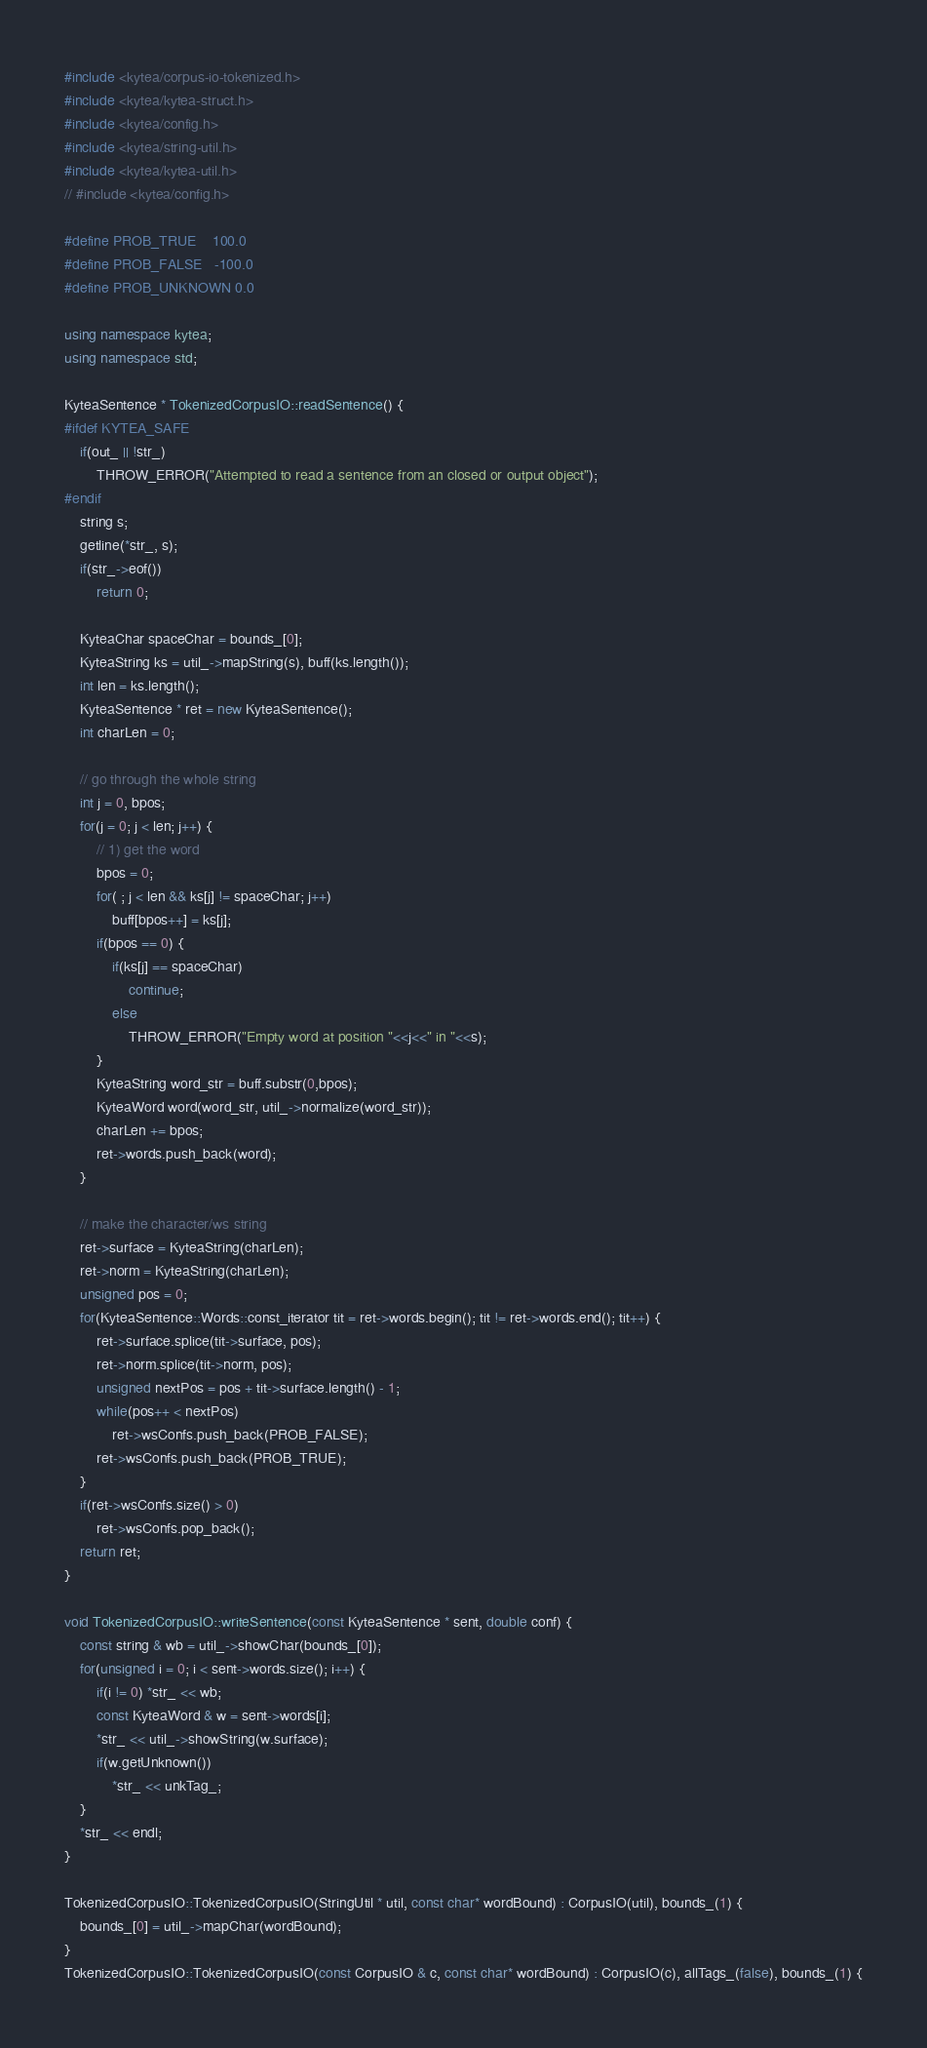Convert code to text. <code><loc_0><loc_0><loc_500><loc_500><_C++_>#include <kytea/corpus-io-tokenized.h>
#include <kytea/kytea-struct.h>
#include <kytea/config.h>
#include <kytea/string-util.h>
#include <kytea/kytea-util.h>
// #include <kytea/config.h>

#define PROB_TRUE    100.0
#define PROB_FALSE   -100.0
#define PROB_UNKNOWN 0.0

using namespace kytea;
using namespace std;

KyteaSentence * TokenizedCorpusIO::readSentence() {
#ifdef KYTEA_SAFE
    if(out_ || !str_)
        THROW_ERROR("Attempted to read a sentence from an closed or output object");
#endif
    string s;
    getline(*str_, s);
    if(str_->eof())
        return 0;

    KyteaChar spaceChar = bounds_[0];
    KyteaString ks = util_->mapString(s), buff(ks.length());
    int len = ks.length();
    KyteaSentence * ret = new KyteaSentence();
    int charLen = 0;

    // go through the whole string
    int j = 0, bpos;
    for(j = 0; j < len; j++) {
        // 1) get the word
        bpos = 0;
        for( ; j < len && ks[j] != spaceChar; j++)
            buff[bpos++] = ks[j];
        if(bpos == 0) {
            if(ks[j] == spaceChar)
                continue;
            else
                THROW_ERROR("Empty word at position "<<j<<" in "<<s);
        }
        KyteaString word_str = buff.substr(0,bpos);
        KyteaWord word(word_str, util_->normalize(word_str));
        charLen += bpos;
        ret->words.push_back(word);
    }

    // make the character/ws string
    ret->surface = KyteaString(charLen);
    ret->norm = KyteaString(charLen);
    unsigned pos = 0;
    for(KyteaSentence::Words::const_iterator tit = ret->words.begin(); tit != ret->words.end(); tit++) {
        ret->surface.splice(tit->surface, pos);
        ret->norm.splice(tit->norm, pos);
        unsigned nextPos = pos + tit->surface.length() - 1;
        while(pos++ < nextPos)
            ret->wsConfs.push_back(PROB_FALSE);
        ret->wsConfs.push_back(PROB_TRUE);
    }
    if(ret->wsConfs.size() > 0)
        ret->wsConfs.pop_back();
    return ret;
}

void TokenizedCorpusIO::writeSentence(const KyteaSentence * sent, double conf) {
    const string & wb = util_->showChar(bounds_[0]);
    for(unsigned i = 0; i < sent->words.size(); i++) {
        if(i != 0) *str_ << wb;
        const KyteaWord & w = sent->words[i];
        *str_ << util_->showString(w.surface);
        if(w.getUnknown())
            *str_ << unkTag_;
    }
    *str_ << endl;
}

TokenizedCorpusIO::TokenizedCorpusIO(StringUtil * util, const char* wordBound) : CorpusIO(util), bounds_(1) {
    bounds_[0] = util_->mapChar(wordBound);
}
TokenizedCorpusIO::TokenizedCorpusIO(const CorpusIO & c, const char* wordBound) : CorpusIO(c), allTags_(false), bounds_(1) {</code> 